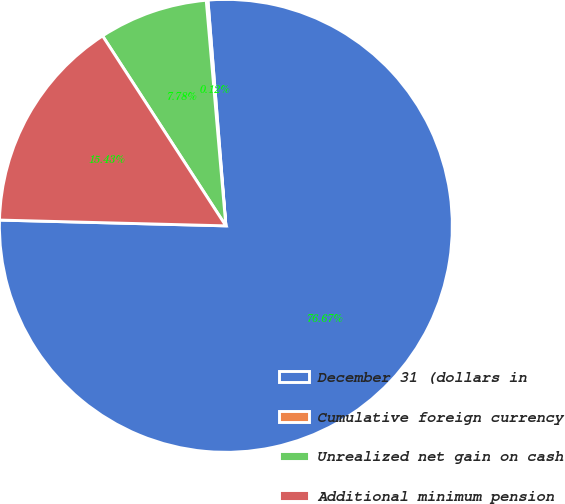Convert chart to OTSL. <chart><loc_0><loc_0><loc_500><loc_500><pie_chart><fcel>December 31 (dollars in<fcel>Cumulative foreign currency<fcel>Unrealized net gain on cash<fcel>Additional minimum pension<nl><fcel>76.67%<fcel>0.12%<fcel>7.78%<fcel>15.43%<nl></chart> 